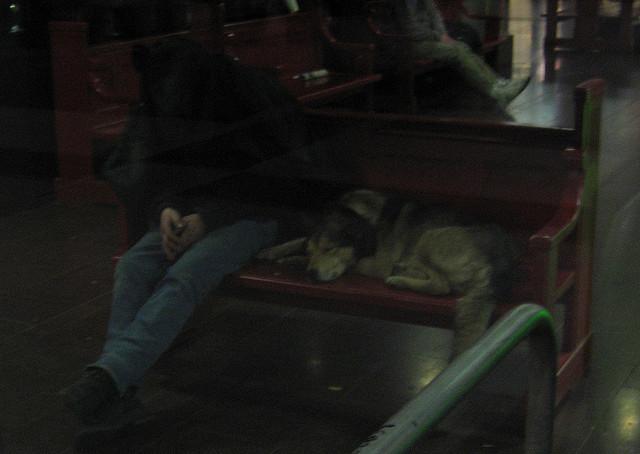How many people are in this image?
Quick response, please. 2. What is the breed of dog?
Give a very brief answer. German shepherd. Would Patrick Swayze's ghost be afraid of these shadows?
Write a very short answer. No. What is the view outside the window?
Short answer required. Dark. Is the dog taking a nap?
Quick response, please. Yes. Is the dog sleeping?
Concise answer only. Yes. 